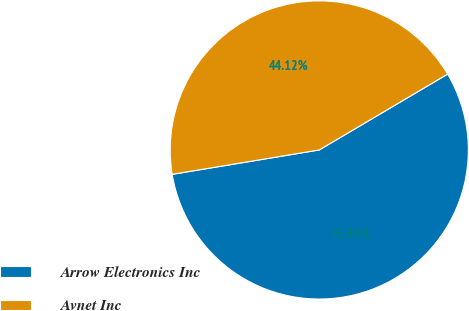<chart> <loc_0><loc_0><loc_500><loc_500><pie_chart><fcel>Arrow Electronics Inc<fcel>Avnet Inc<nl><fcel>55.88%<fcel>44.12%<nl></chart> 